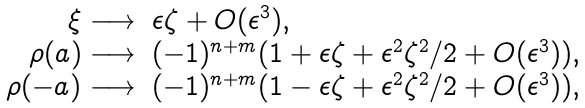Convert formula to latex. <formula><loc_0><loc_0><loc_500><loc_500>\begin{array} { r l } \xi \longrightarrow & \epsilon \zeta + O ( \epsilon ^ { 3 } ) , \\ \rho ( a ) \longrightarrow & ( - 1 ) ^ { n + m } ( 1 + \epsilon \zeta + \epsilon ^ { 2 } \zeta ^ { 2 } / 2 + O ( \epsilon ^ { 3 } ) ) , \\ \rho ( - a ) \longrightarrow & ( - 1 ) ^ { n + m } ( 1 - \epsilon \zeta + \epsilon ^ { 2 } \zeta ^ { 2 } / 2 + O ( \epsilon ^ { 3 } ) ) , \\ \end{array}</formula> 